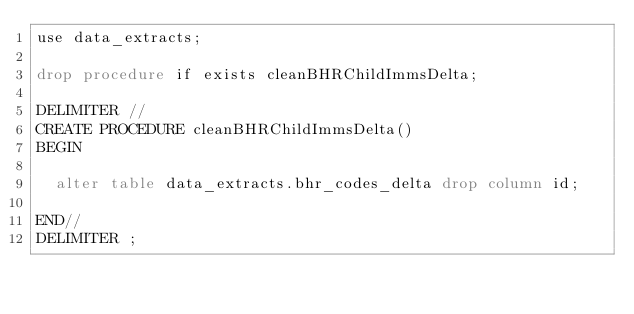<code> <loc_0><loc_0><loc_500><loc_500><_SQL_>use data_extracts;

drop procedure if exists cleanBHRChildImmsDelta;

DELIMITER //
CREATE PROCEDURE cleanBHRChildImmsDelta()
BEGIN

  alter table data_extracts.bhr_codes_delta drop column id;

END//
DELIMITER ;
</code> 